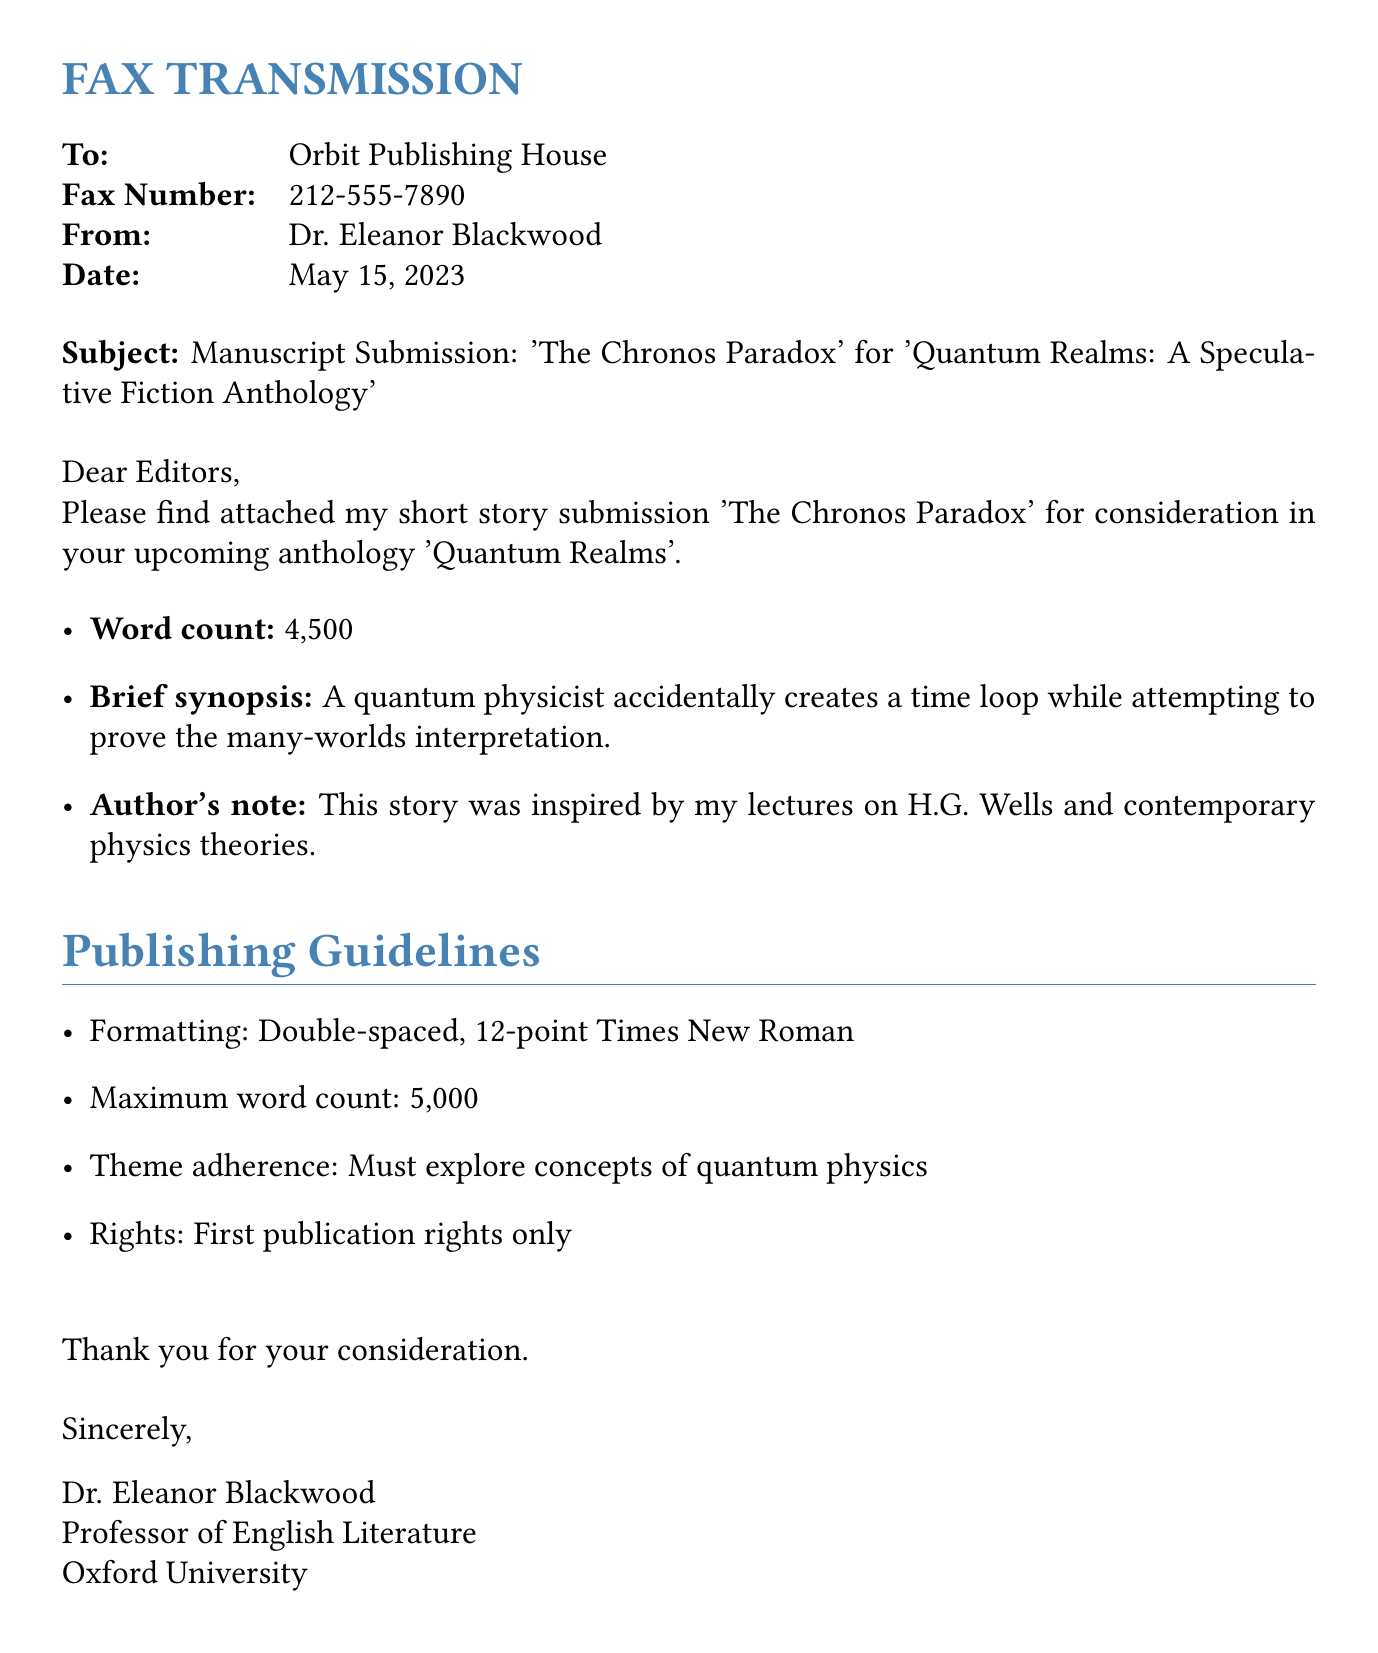What is the title of the manuscript? The title of the manuscript is stated in the subject line of the fax.
Answer: The Chronos Paradox Who is the author of the manuscript? The author is mentioned in the sender information of the fax.
Answer: Dr. Eleanor Blackwood What is the word count of the manuscript? The word count is provided in the details included in the document.
Answer: 4,500 What is the fax number of the receiving party? The fax number is included in the header section of the fax.
Answer: 212-555-7890 What rights are being requested for the manuscript? The rights information is listed under publishing guidelines in the document.
Answer: First publication rights only What is the maximum word count for submissions? The maximum word count is specified in the publishing guidelines section.
Answer: 5,000 What theme must the submission explore? The required theme is noted in the publishing guidelines section of the document.
Answer: Quantum physics What inspired the author's story? The author's inspiration is mentioned in the author's note section of the fax.
Answer: Lectures on H.G. Wells and contemporary physics theories What is the date of the fax submission? The date is noted in the header section of the fax.
Answer: May 15, 2023 